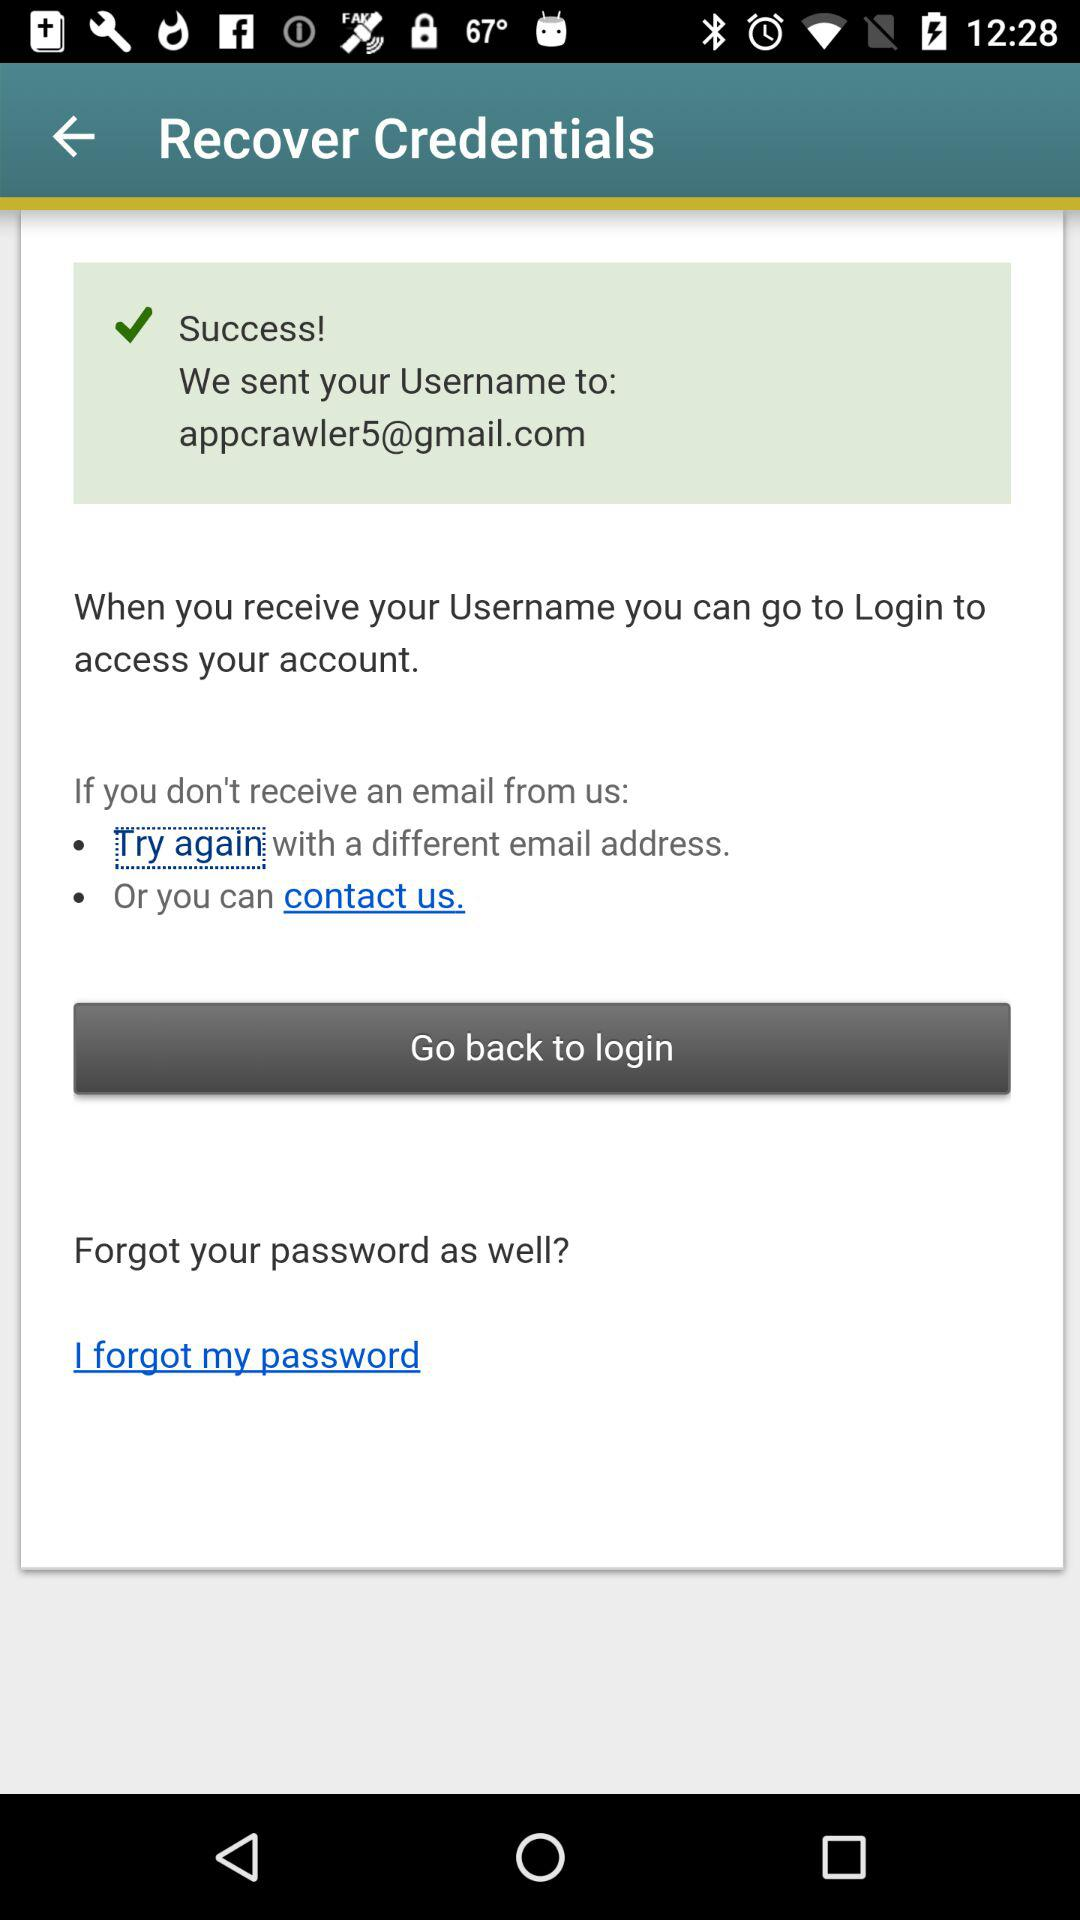What is the email address? The email address is appcrawler5@gmail.com. 